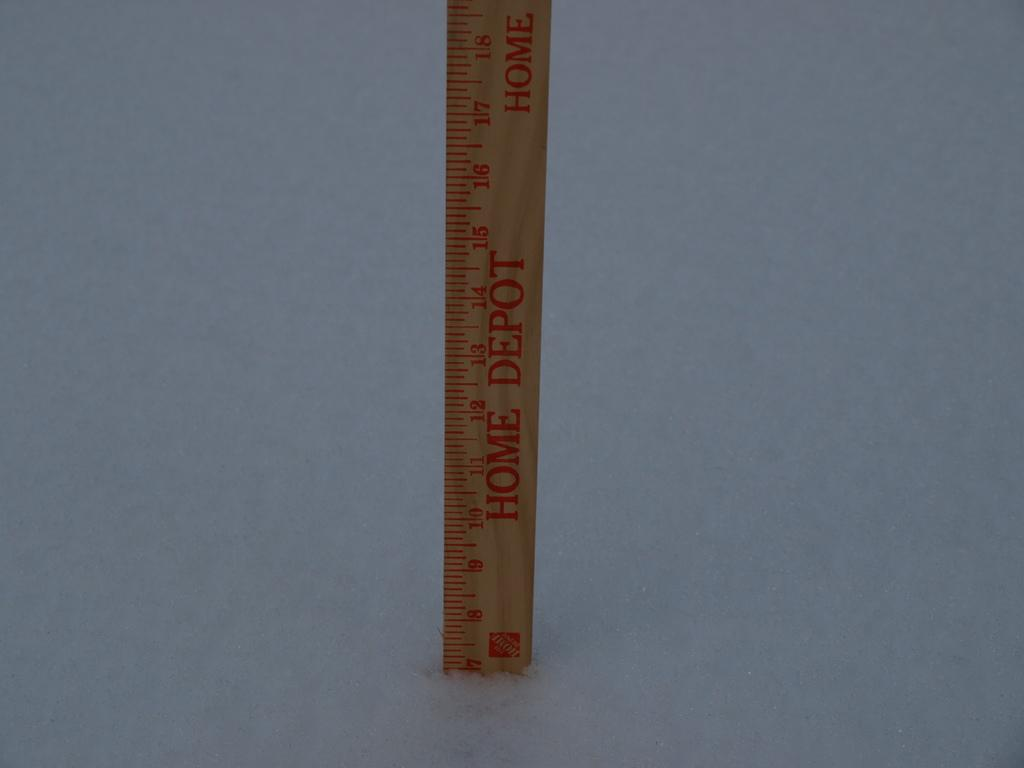<image>
Describe the image concisely. A wooden measuring stick from the Home Depot. 